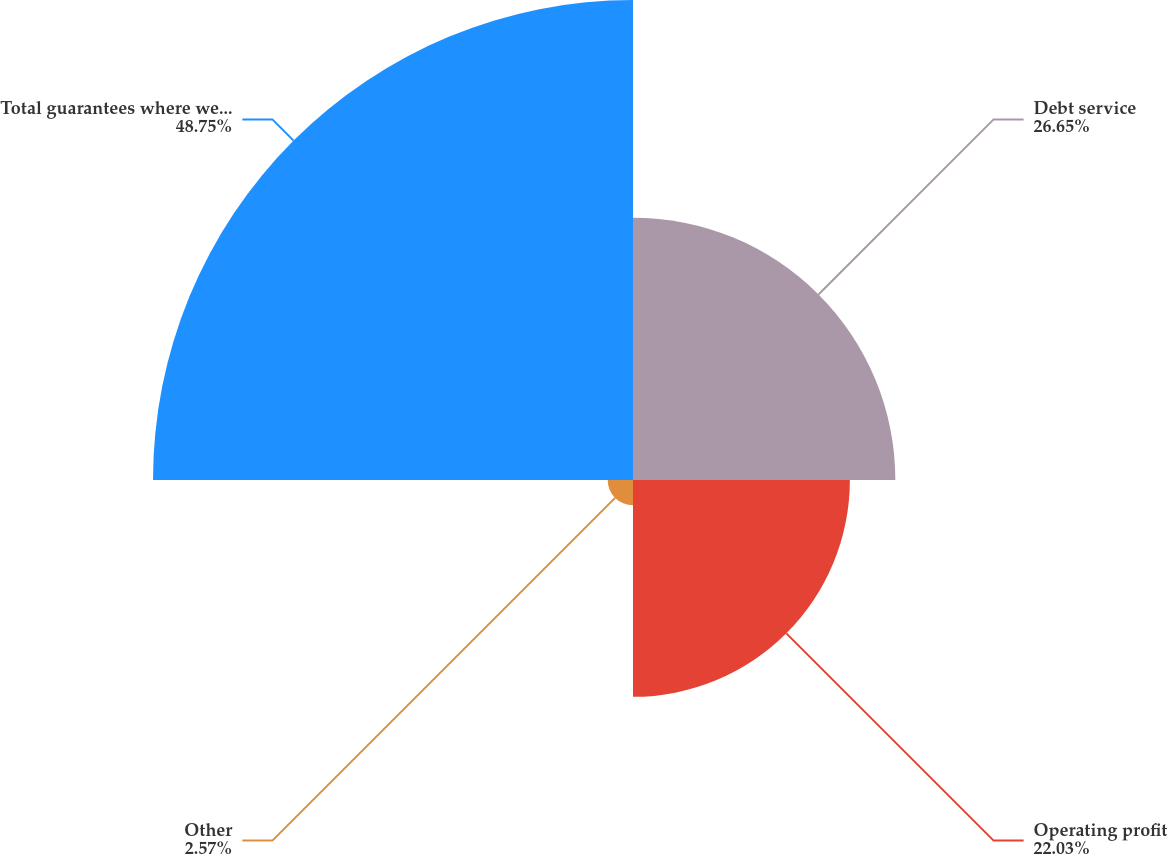Convert chart to OTSL. <chart><loc_0><loc_0><loc_500><loc_500><pie_chart><fcel>Debt service<fcel>Operating profit<fcel>Other<fcel>Total guarantees where we are<nl><fcel>26.65%<fcel>22.03%<fcel>2.57%<fcel>48.76%<nl></chart> 